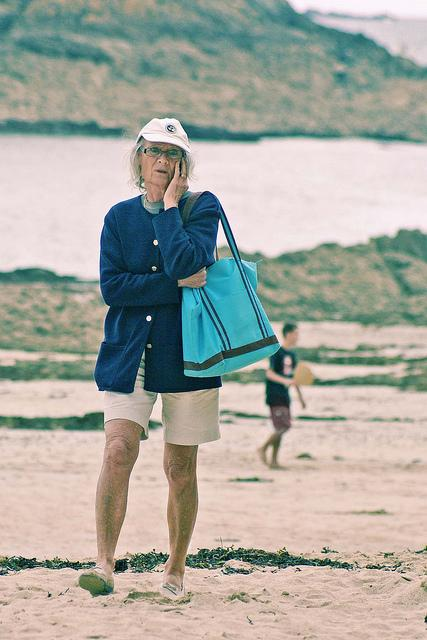What is the old woman doing? Please explain your reasoning. using phone. She is holding it to her ear. 